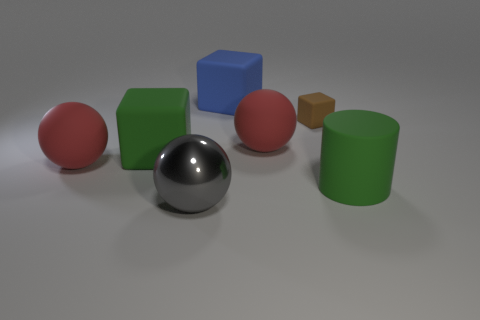Is there anything else that has the same material as the gray thing?
Provide a short and direct response. No. What color is the cube that is both on the right side of the large shiny object and to the left of the tiny brown rubber block?
Your answer should be compact. Blue. There is a red rubber thing that is on the left side of the gray shiny sphere; does it have the same shape as the object in front of the big green cylinder?
Provide a short and direct response. Yes. What material is the large object that is behind the brown block?
Give a very brief answer. Rubber. How many objects are large green rubber objects that are to the right of the big green cube or green rubber cylinders?
Provide a short and direct response. 1. Is the number of small matte cubes right of the cylinder the same as the number of big metal balls?
Offer a very short reply. No. Does the green rubber block have the same size as the blue rubber cube?
Give a very brief answer. Yes. What is the color of the cylinder that is the same size as the blue object?
Your answer should be compact. Green. Does the green rubber cube have the same size as the red matte ball to the left of the blue rubber cube?
Keep it short and to the point. Yes. How many cubes have the same color as the cylinder?
Make the answer very short. 1. 